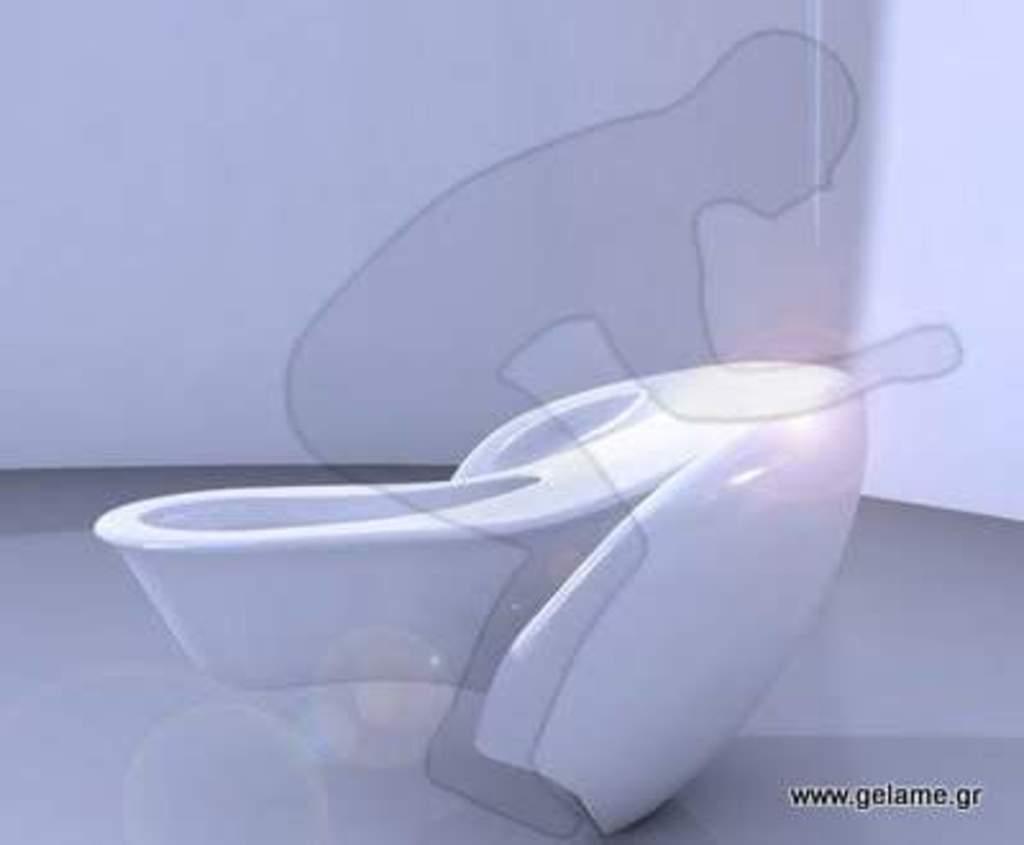Please provide a concise description of this image. In this image we can see a toilet. In the back there is a wall. Also we can see drawing of a person. In the right bottom corner there is something written. 